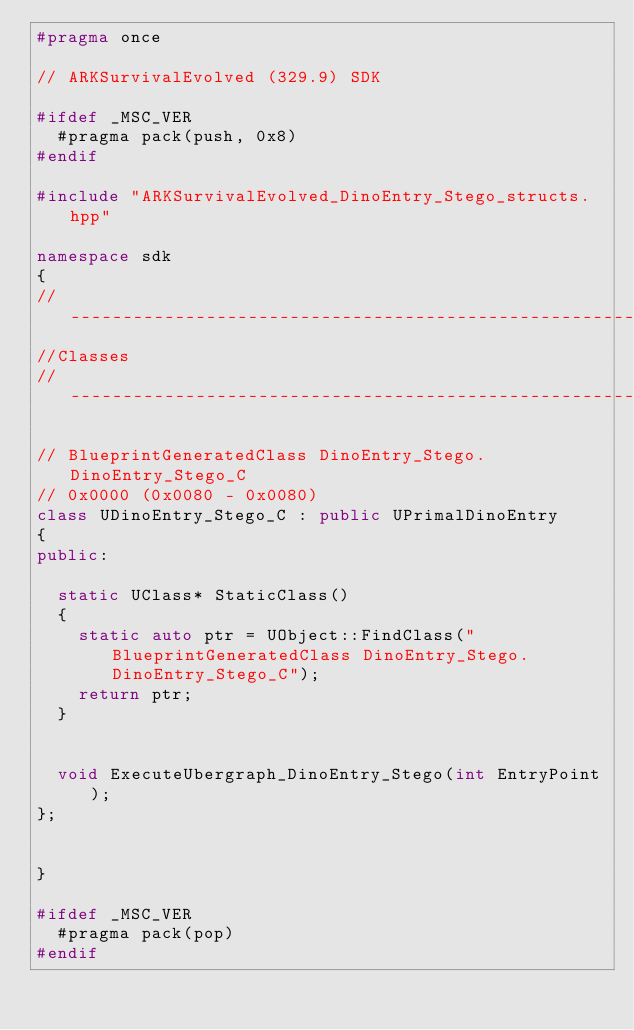Convert code to text. <code><loc_0><loc_0><loc_500><loc_500><_C++_>#pragma once

// ARKSurvivalEvolved (329.9) SDK

#ifdef _MSC_VER
	#pragma pack(push, 0x8)
#endif

#include "ARKSurvivalEvolved_DinoEntry_Stego_structs.hpp"

namespace sdk
{
//---------------------------------------------------------------------------
//Classes
//---------------------------------------------------------------------------

// BlueprintGeneratedClass DinoEntry_Stego.DinoEntry_Stego_C
// 0x0000 (0x0080 - 0x0080)
class UDinoEntry_Stego_C : public UPrimalDinoEntry
{
public:

	static UClass* StaticClass()
	{
		static auto ptr = UObject::FindClass("BlueprintGeneratedClass DinoEntry_Stego.DinoEntry_Stego_C");
		return ptr;
	}


	void ExecuteUbergraph_DinoEntry_Stego(int EntryPoint);
};


}

#ifdef _MSC_VER
	#pragma pack(pop)
#endif
</code> 